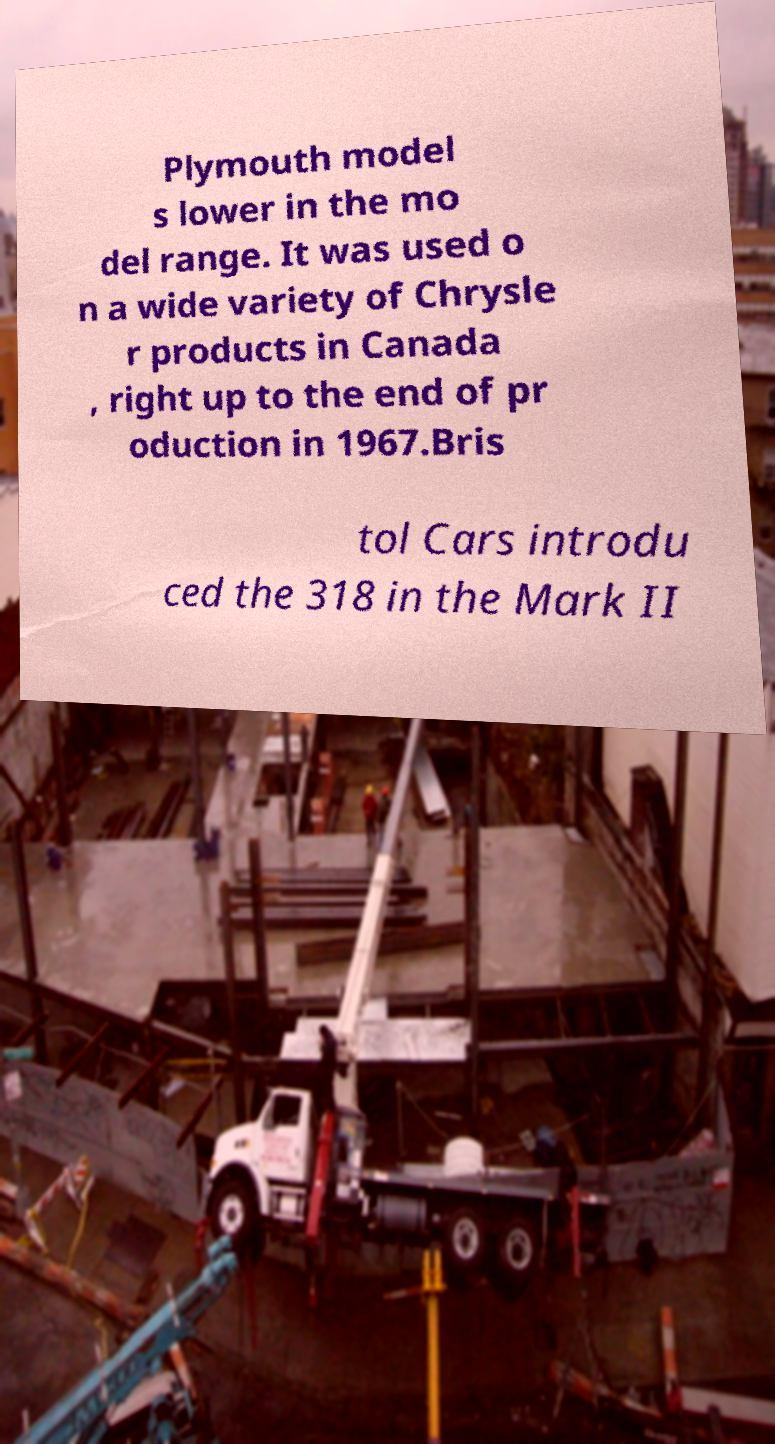There's text embedded in this image that I need extracted. Can you transcribe it verbatim? Plymouth model s lower in the mo del range. It was used o n a wide variety of Chrysle r products in Canada , right up to the end of pr oduction in 1967.Bris tol Cars introdu ced the 318 in the Mark II 